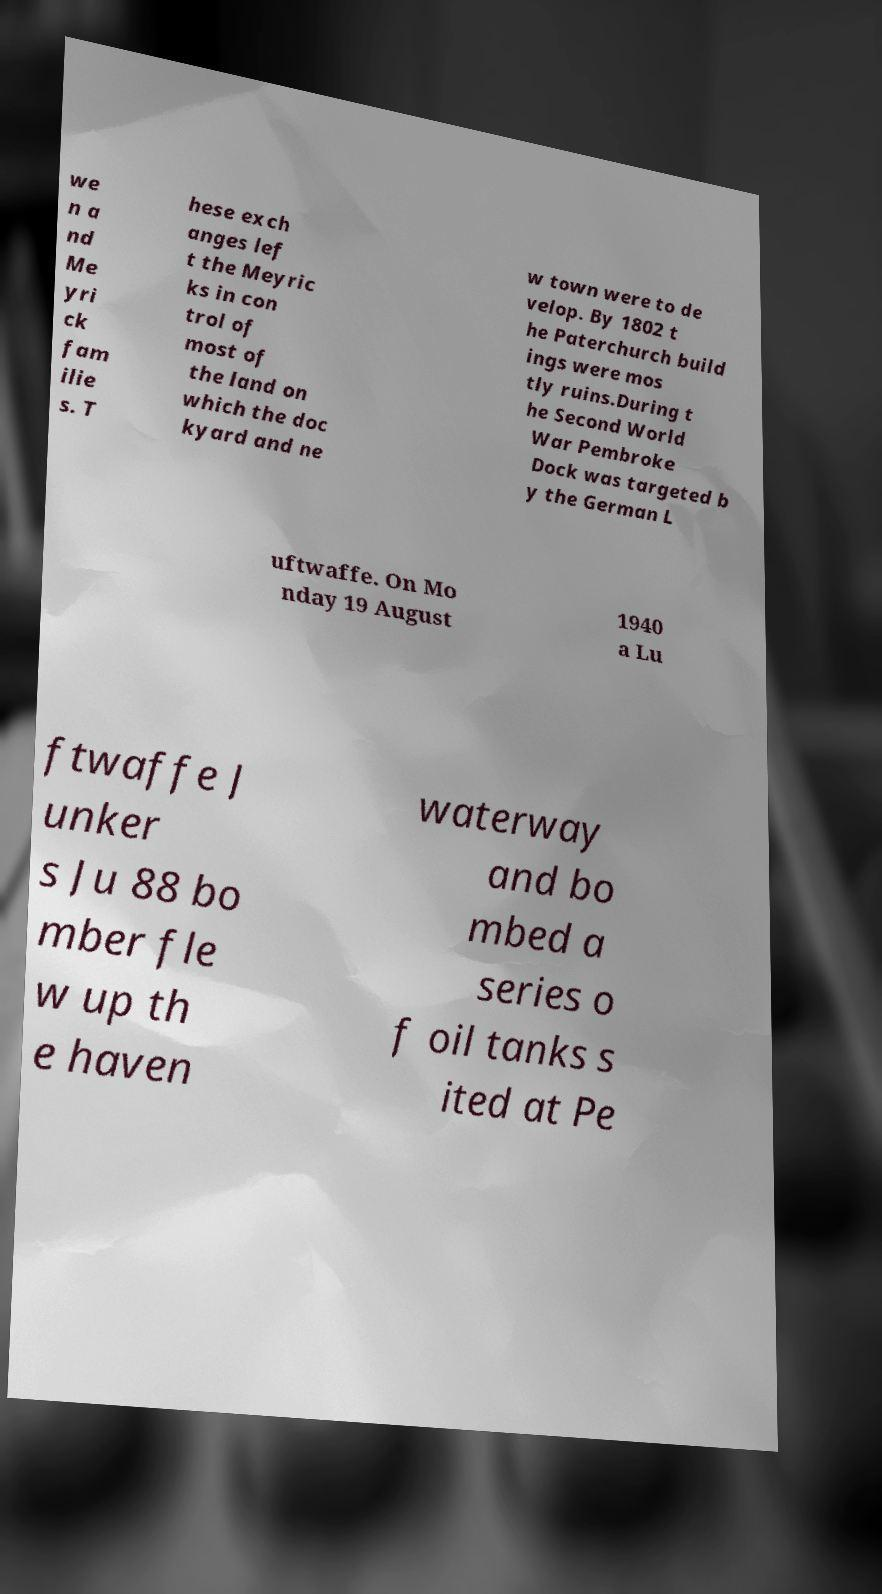Please identify and transcribe the text found in this image. we n a nd Me yri ck fam ilie s. T hese exch anges lef t the Meyric ks in con trol of most of the land on which the doc kyard and ne w town were to de velop. By 1802 t he Paterchurch build ings were mos tly ruins.During t he Second World War Pembroke Dock was targeted b y the German L uftwaffe. On Mo nday 19 August 1940 a Lu ftwaffe J unker s Ju 88 bo mber fle w up th e haven waterway and bo mbed a series o f oil tanks s ited at Pe 